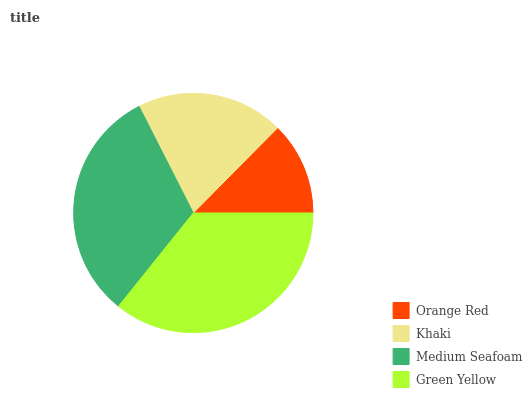Is Orange Red the minimum?
Answer yes or no. Yes. Is Green Yellow the maximum?
Answer yes or no. Yes. Is Khaki the minimum?
Answer yes or no. No. Is Khaki the maximum?
Answer yes or no. No. Is Khaki greater than Orange Red?
Answer yes or no. Yes. Is Orange Red less than Khaki?
Answer yes or no. Yes. Is Orange Red greater than Khaki?
Answer yes or no. No. Is Khaki less than Orange Red?
Answer yes or no. No. Is Medium Seafoam the high median?
Answer yes or no. Yes. Is Khaki the low median?
Answer yes or no. Yes. Is Green Yellow the high median?
Answer yes or no. No. Is Orange Red the low median?
Answer yes or no. No. 